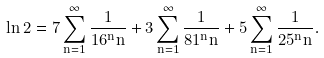<formula> <loc_0><loc_0><loc_500><loc_500>\ln 2 = 7 \sum _ { n = 1 } ^ { \infty } { \frac { 1 } { 1 6 ^ { n } n } } + 3 \sum _ { n = 1 } ^ { \infty } { \frac { 1 } { 8 1 ^ { n } n } } + 5 \sum _ { n = 1 } ^ { \infty } { \frac { 1 } { 2 5 ^ { n } n } } .</formula> 